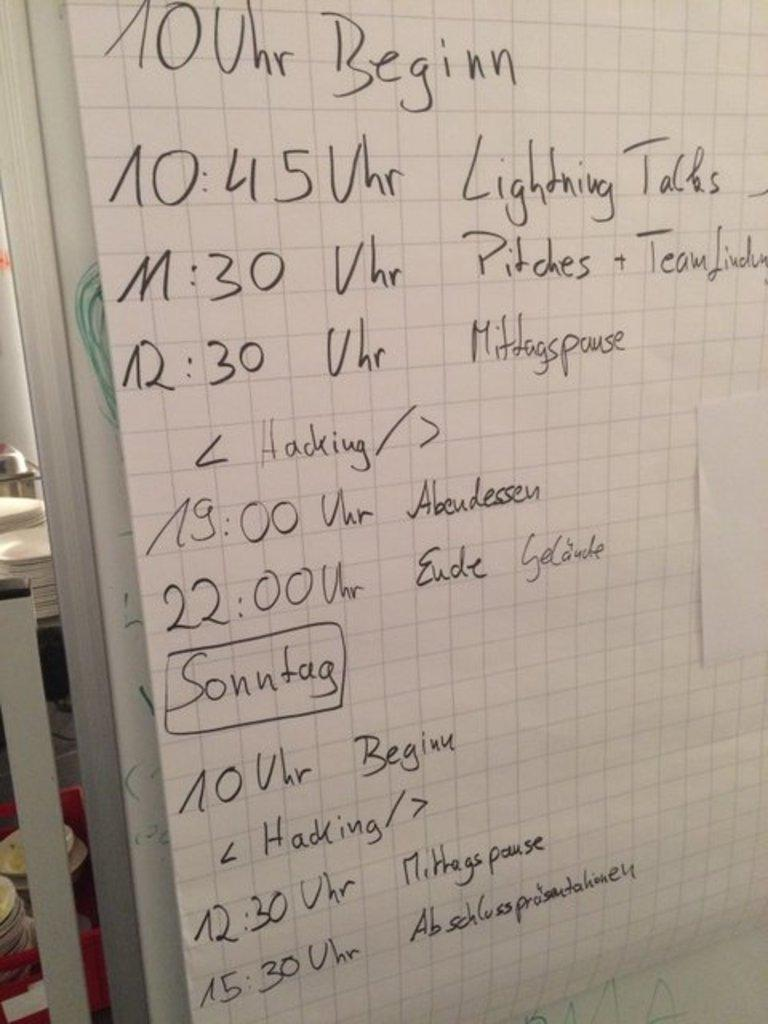<image>
Describe the image concisely. On a large sheet of graph paper, draped over a dry erase board is an event schedule that goes from 10:00 to 15:30. 